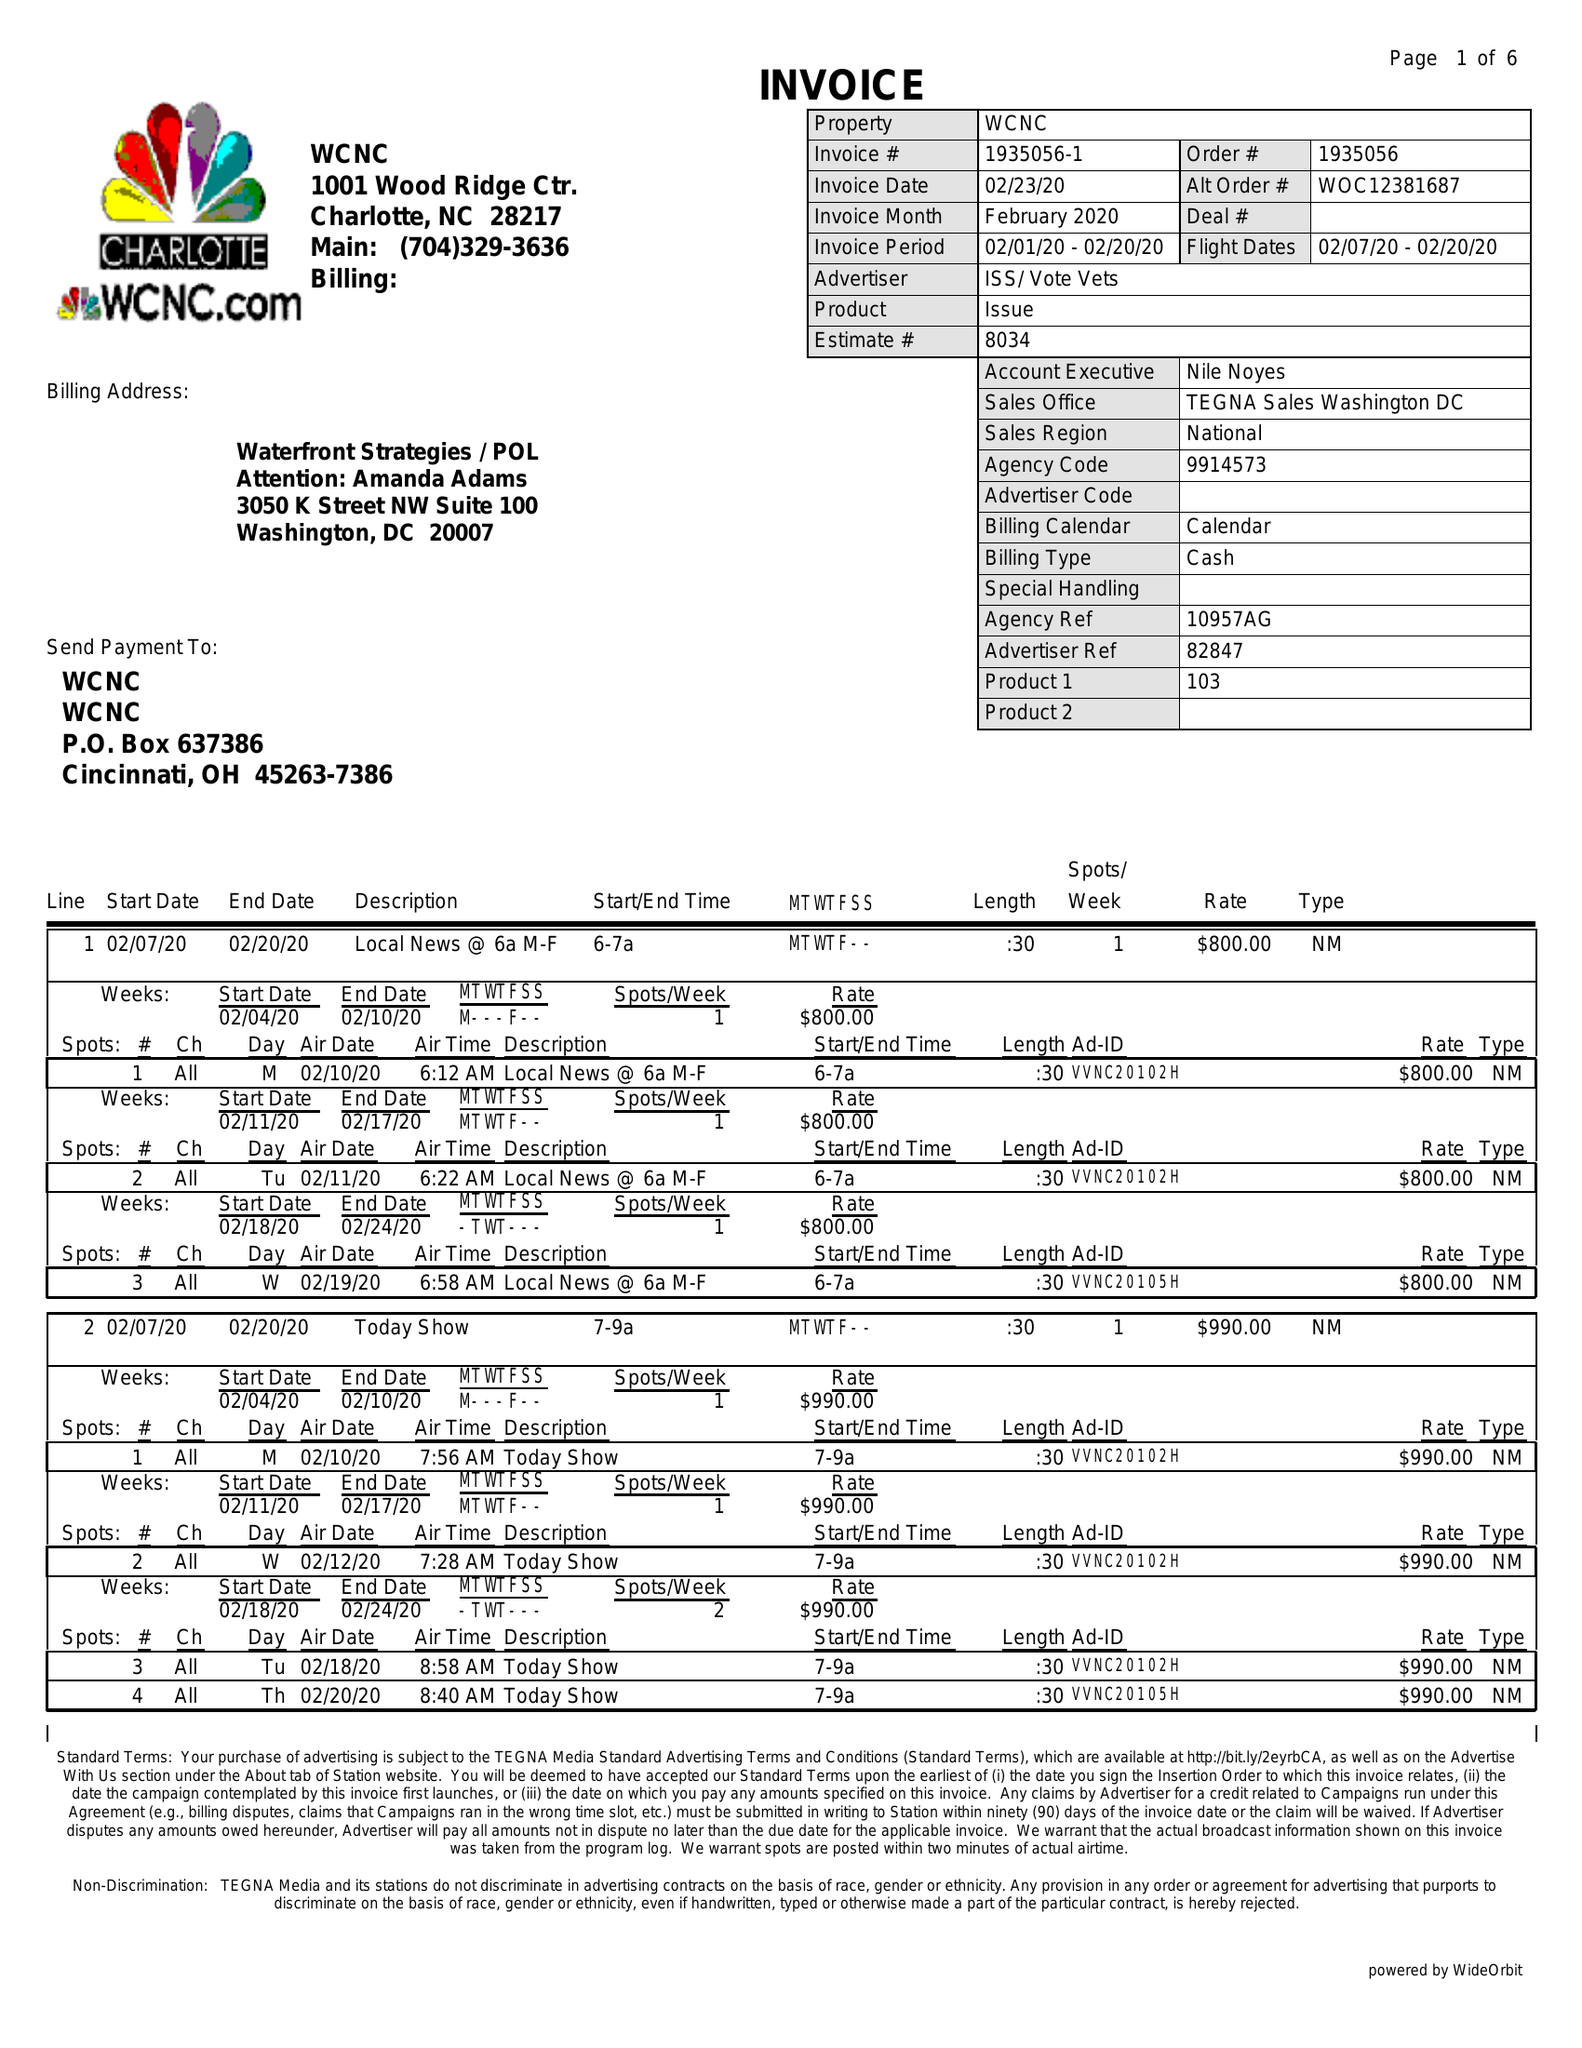What is the value for the gross_amount?
Answer the question using a single word or phrase. 114420.00 